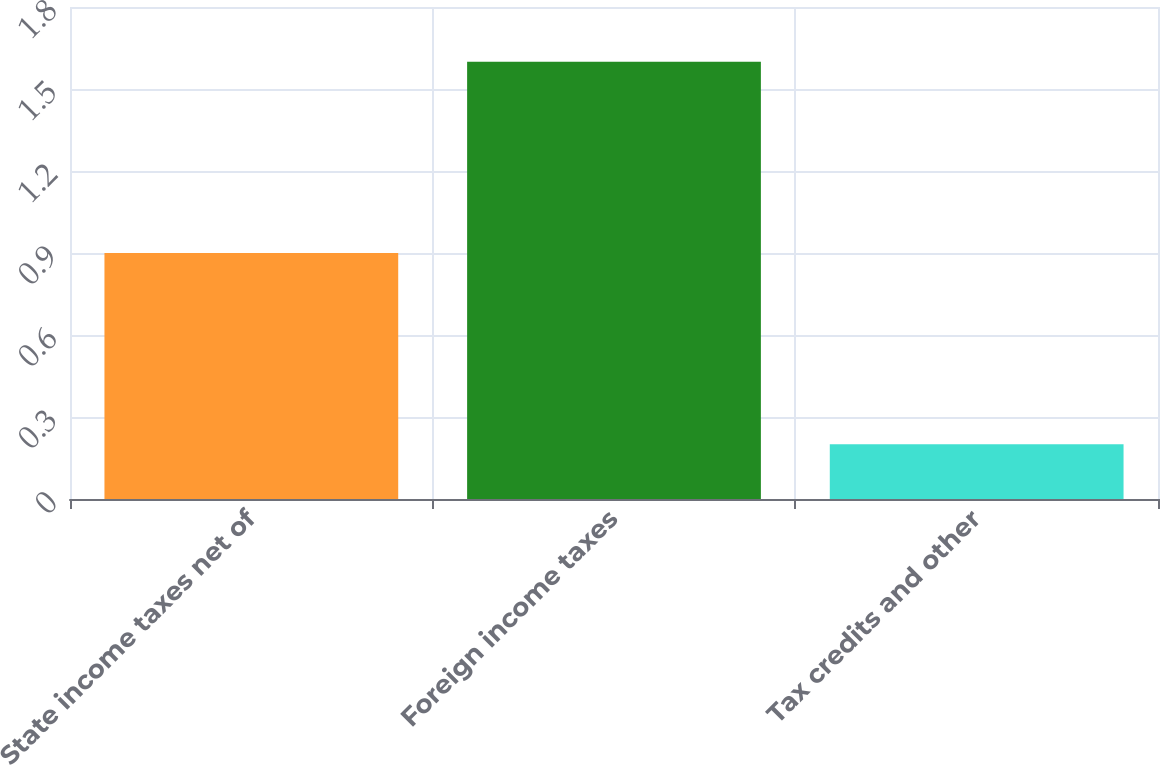Convert chart. <chart><loc_0><loc_0><loc_500><loc_500><bar_chart><fcel>State income taxes net of<fcel>Foreign income taxes<fcel>Tax credits and other<nl><fcel>0.9<fcel>1.6<fcel>0.2<nl></chart> 